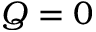Convert formula to latex. <formula><loc_0><loc_0><loc_500><loc_500>Q = 0</formula> 